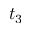<formula> <loc_0><loc_0><loc_500><loc_500>t _ { 3 }</formula> 